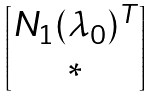<formula> <loc_0><loc_0><loc_500><loc_500>\begin{bmatrix} N _ { 1 } ( \lambda _ { 0 } ) ^ { T } \\ * \end{bmatrix}</formula> 